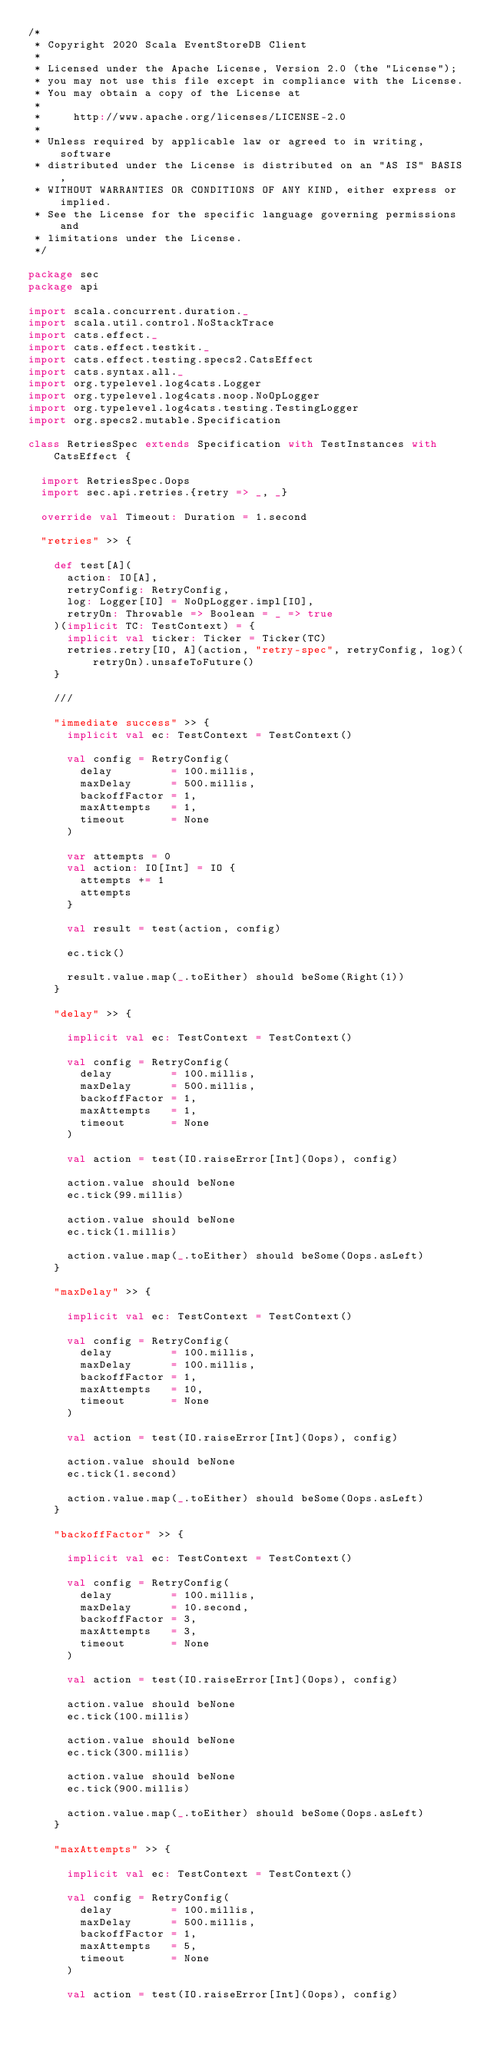<code> <loc_0><loc_0><loc_500><loc_500><_Scala_>/*
 * Copyright 2020 Scala EventStoreDB Client
 *
 * Licensed under the Apache License, Version 2.0 (the "License");
 * you may not use this file except in compliance with the License.
 * You may obtain a copy of the License at
 *
 *     http://www.apache.org/licenses/LICENSE-2.0
 *
 * Unless required by applicable law or agreed to in writing, software
 * distributed under the License is distributed on an "AS IS" BASIS,
 * WITHOUT WARRANTIES OR CONDITIONS OF ANY KIND, either express or implied.
 * See the License for the specific language governing permissions and
 * limitations under the License.
 */

package sec
package api

import scala.concurrent.duration._
import scala.util.control.NoStackTrace
import cats.effect._
import cats.effect.testkit._
import cats.effect.testing.specs2.CatsEffect
import cats.syntax.all._
import org.typelevel.log4cats.Logger
import org.typelevel.log4cats.noop.NoOpLogger
import org.typelevel.log4cats.testing.TestingLogger
import org.specs2.mutable.Specification

class RetriesSpec extends Specification with TestInstances with CatsEffect {

  import RetriesSpec.Oops
  import sec.api.retries.{retry => _, _}

  override val Timeout: Duration = 1.second

  "retries" >> {

    def test[A](
      action: IO[A],
      retryConfig: RetryConfig,
      log: Logger[IO] = NoOpLogger.impl[IO],
      retryOn: Throwable => Boolean = _ => true
    )(implicit TC: TestContext) = {
      implicit val ticker: Ticker = Ticker(TC)
      retries.retry[IO, A](action, "retry-spec", retryConfig, log)(retryOn).unsafeToFuture()
    }

    ///

    "immediate success" >> {
      implicit val ec: TestContext = TestContext()

      val config = RetryConfig(
        delay         = 100.millis,
        maxDelay      = 500.millis,
        backoffFactor = 1,
        maxAttempts   = 1,
        timeout       = None
      )

      var attempts = 0
      val action: IO[Int] = IO {
        attempts += 1
        attempts
      }

      val result = test(action, config)

      ec.tick()

      result.value.map(_.toEither) should beSome(Right(1))
    }

    "delay" >> {

      implicit val ec: TestContext = TestContext()

      val config = RetryConfig(
        delay         = 100.millis,
        maxDelay      = 500.millis,
        backoffFactor = 1,
        maxAttempts   = 1,
        timeout       = None
      )

      val action = test(IO.raiseError[Int](Oops), config)

      action.value should beNone
      ec.tick(99.millis)

      action.value should beNone
      ec.tick(1.millis)

      action.value.map(_.toEither) should beSome(Oops.asLeft)
    }

    "maxDelay" >> {

      implicit val ec: TestContext = TestContext()

      val config = RetryConfig(
        delay         = 100.millis,
        maxDelay      = 100.millis,
        backoffFactor = 1,
        maxAttempts   = 10,
        timeout       = None
      )

      val action = test(IO.raiseError[Int](Oops), config)

      action.value should beNone
      ec.tick(1.second)

      action.value.map(_.toEither) should beSome(Oops.asLeft)
    }

    "backoffFactor" >> {

      implicit val ec: TestContext = TestContext()

      val config = RetryConfig(
        delay         = 100.millis,
        maxDelay      = 10.second,
        backoffFactor = 3,
        maxAttempts   = 3,
        timeout       = None
      )

      val action = test(IO.raiseError[Int](Oops), config)

      action.value should beNone
      ec.tick(100.millis)

      action.value should beNone
      ec.tick(300.millis)

      action.value should beNone
      ec.tick(900.millis)

      action.value.map(_.toEither) should beSome(Oops.asLeft)
    }

    "maxAttempts" >> {

      implicit val ec: TestContext = TestContext()

      val config = RetryConfig(
        delay         = 100.millis,
        maxDelay      = 500.millis,
        backoffFactor = 1,
        maxAttempts   = 5,
        timeout       = None
      )

      val action = test(IO.raiseError[Int](Oops), config)
</code> 